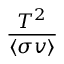Convert formula to latex. <formula><loc_0><loc_0><loc_500><loc_500>\frac { T ^ { 2 } } { \langle \sigma v \rangle }</formula> 